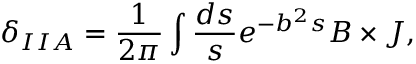Convert formula to latex. <formula><loc_0><loc_0><loc_500><loc_500>\delta _ { I I A } = \frac { 1 } { 2 \pi } \int \frac { d s } { s } e ^ { - b ^ { 2 } s } B \times J ,</formula> 